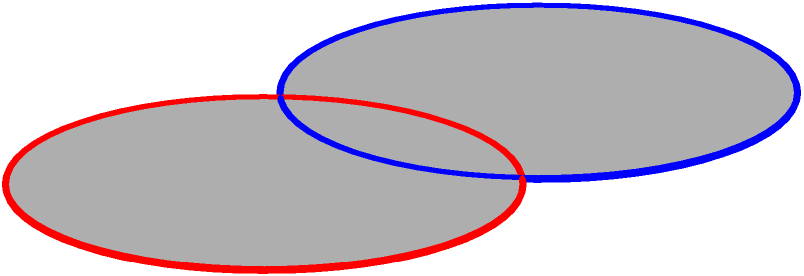Consider two interlinked turntable platters represented by the blue and red circles in the diagram. What is the fundamental group of the space formed by these interlinked platters? To determine the fundamental group of the space formed by the interlinked turntable platters, we can follow these steps:

1. Recognize that this configuration is topologically equivalent to two interlinked circles, also known as the Hopf link.

2. The space formed by the Hopf link is homotopy equivalent to the complement of the trefoil knot in $\mathbb{R}^3$.

3. The fundamental group of the complement of the trefoil knot is known to be isomorphic to the braid group on three strands, denoted as $B_3$.

4. The braid group $B_3$ has the following presentation:
   $B_3 = \langle \sigma_1, \sigma_2 \mid \sigma_1\sigma_2\sigma_1 = \sigma_2\sigma_1\sigma_2 \rangle$

5. This group is non-abelian and has infinite order.

6. In terms of musical interpretation, this means that the paths around the two platters cannot be freely interchanged (non-abelian property), and there are infinitely many distinct ways to loop around the configuration (infinite order).
Answer: $B_3 = \langle \sigma_1, \sigma_2 \mid \sigma_1\sigma_2\sigma_1 = \sigma_2\sigma_1\sigma_2 \rangle$ 